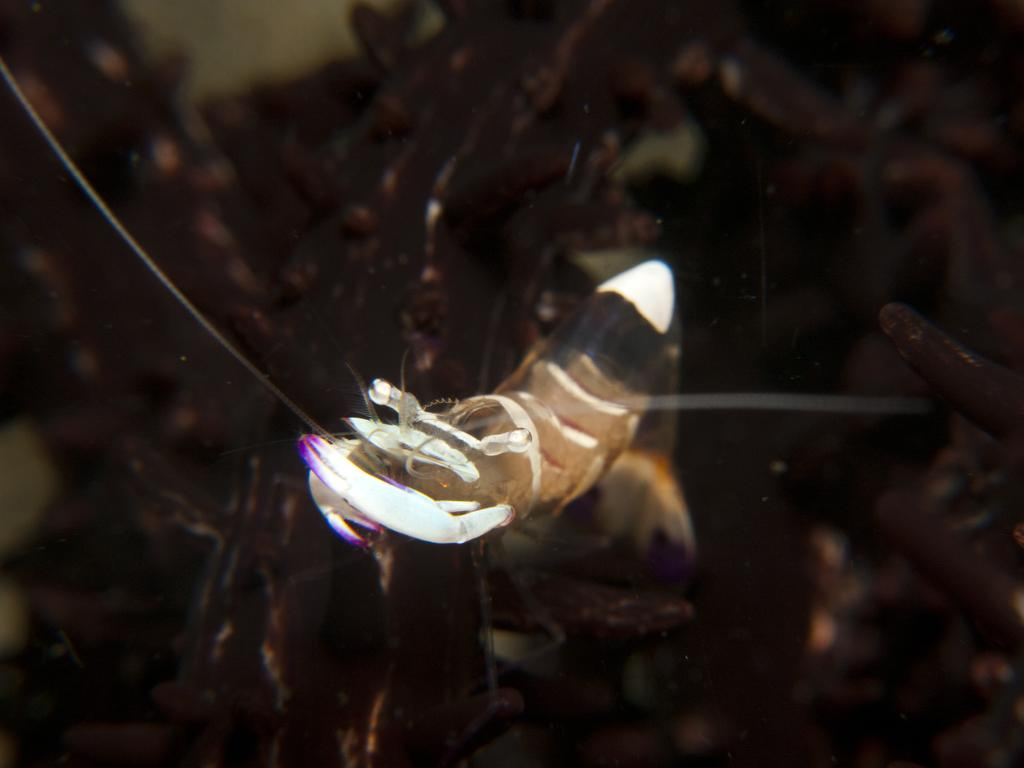What is the main subject in the center of the image? There is an insect in the center of the image. What historical event is depicted in the image involving a bridge and a star? There is no historical event, bridge, or star present in the image; it features an insect in the center. 